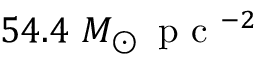<formula> <loc_0><loc_0><loc_500><loc_500>5 4 . 4 M _ { \odot } \, p c ^ { - 2 }</formula> 